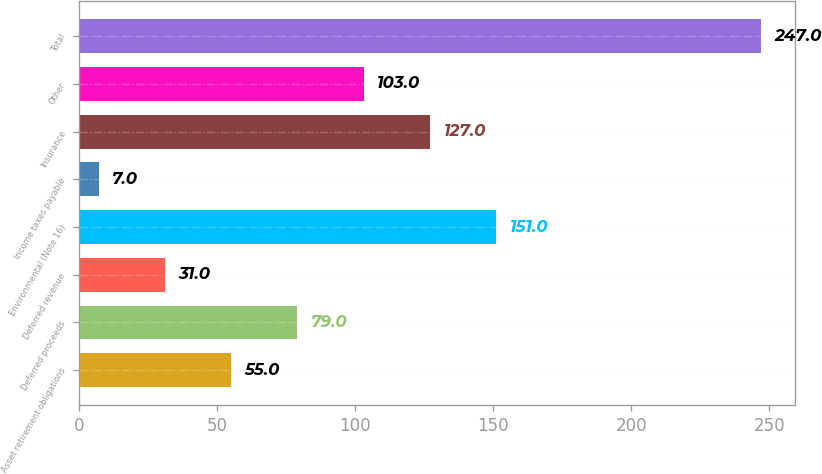Convert chart to OTSL. <chart><loc_0><loc_0><loc_500><loc_500><bar_chart><fcel>Asset retirement obligations<fcel>Deferred proceeds<fcel>Deferred revenue<fcel>Environmental (Note 16)<fcel>Income taxes payable<fcel>Insurance<fcel>Other<fcel>Total<nl><fcel>55<fcel>79<fcel>31<fcel>151<fcel>7<fcel>127<fcel>103<fcel>247<nl></chart> 